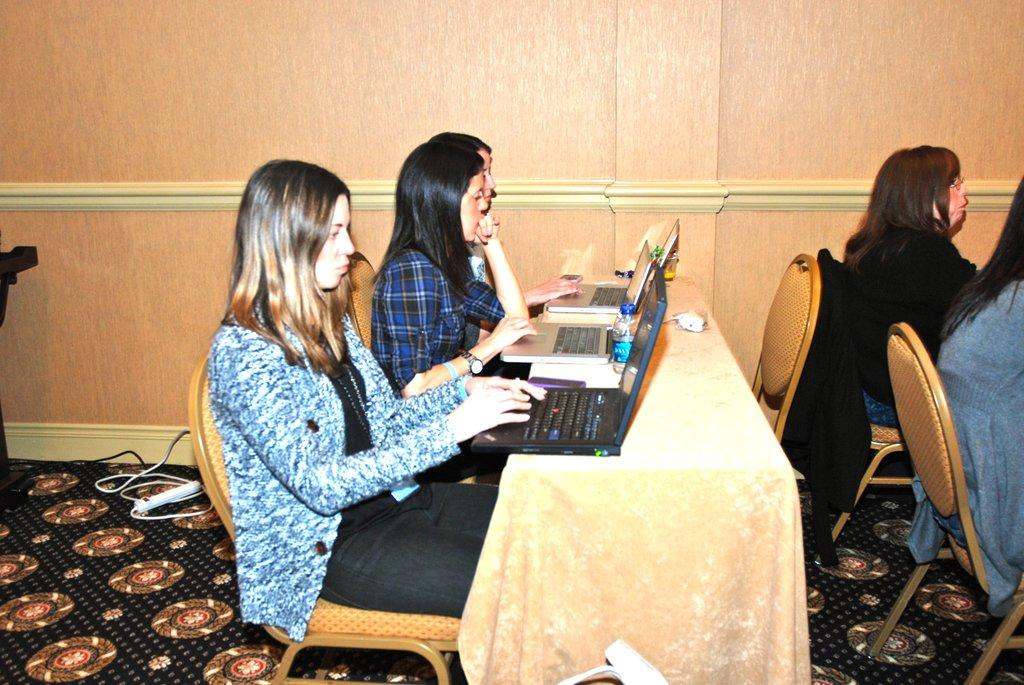What are the people in the image doing? The people in the image are sitting on chairs. What are the people looking at while sitting on the chairs? The people are looking at laptops. Where are the laptops placed in the image? The laptops are on a table. What else can be seen on the table in the image? There is a bottle on the table. How many legs does the pail have in the image? There is no pail present in the image. 